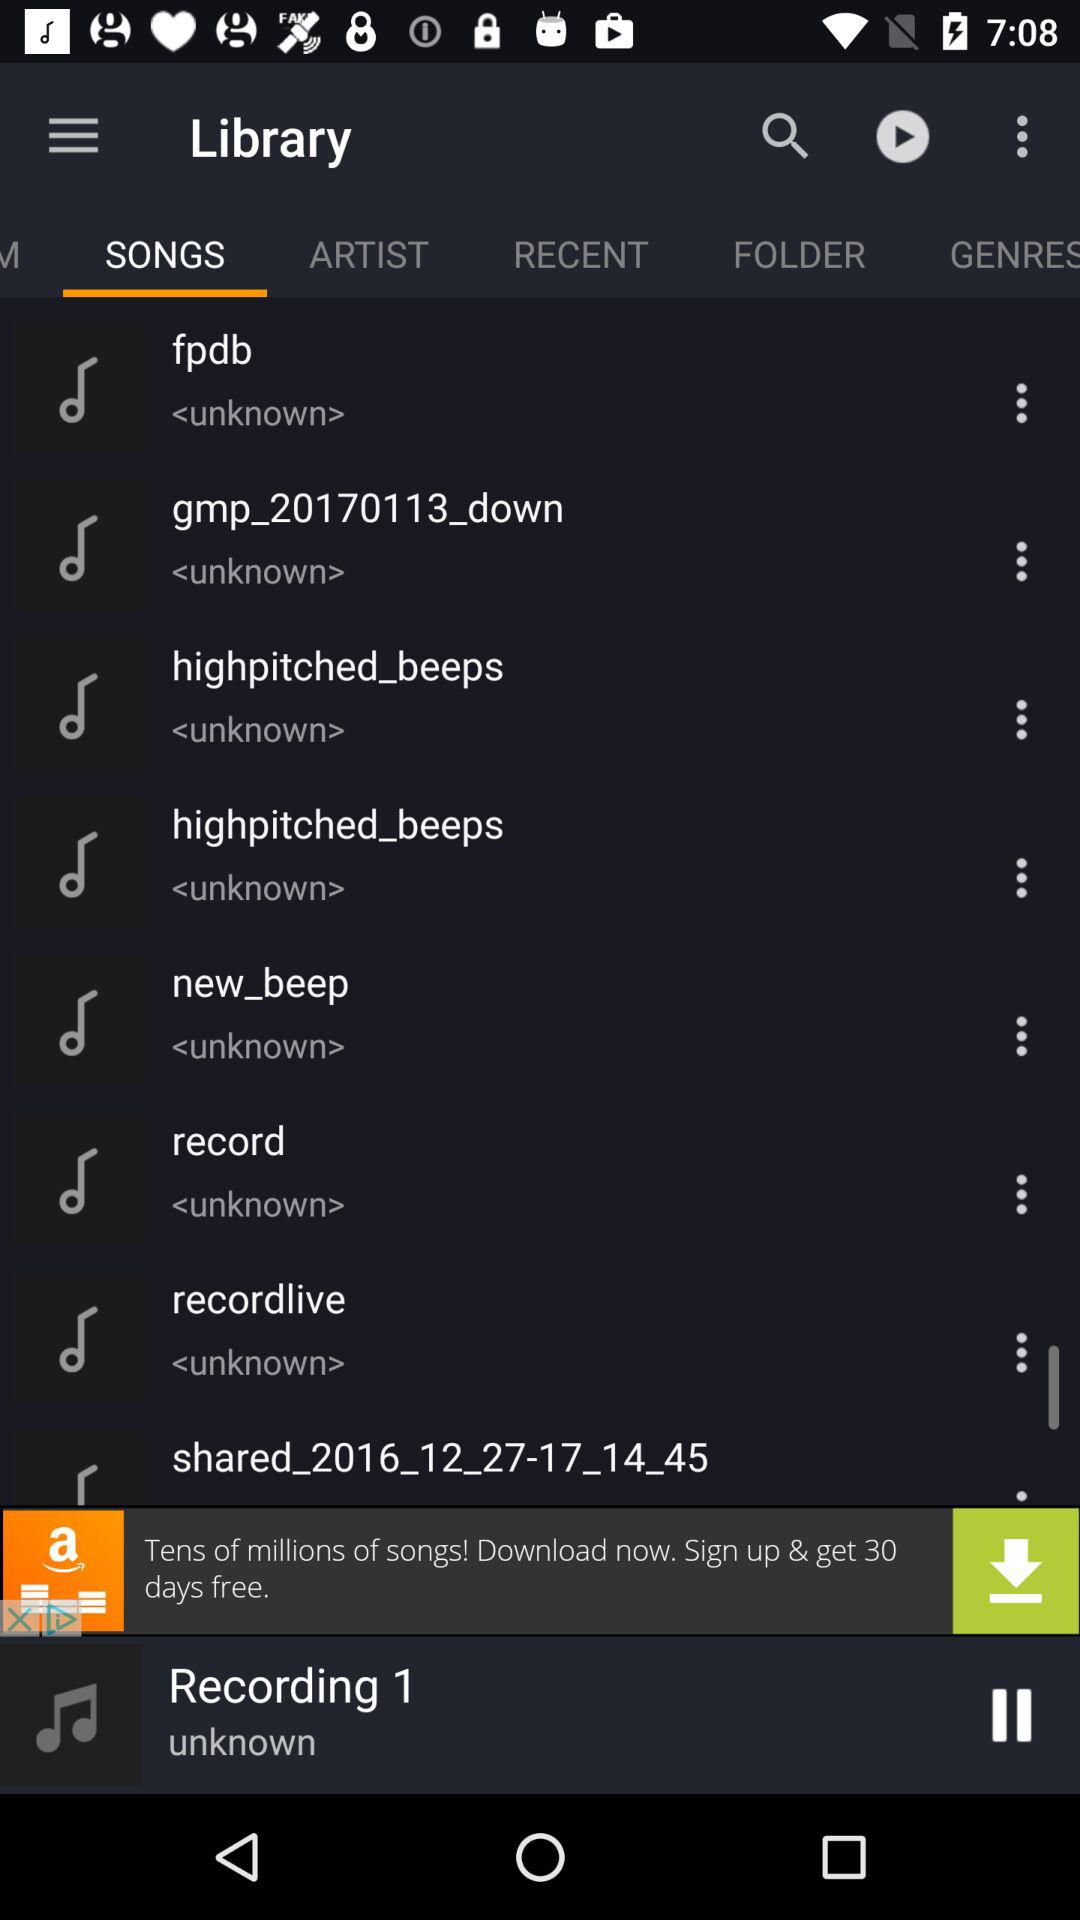Which audio is currently playing? The audio that is currently playing is "Recording 1". 